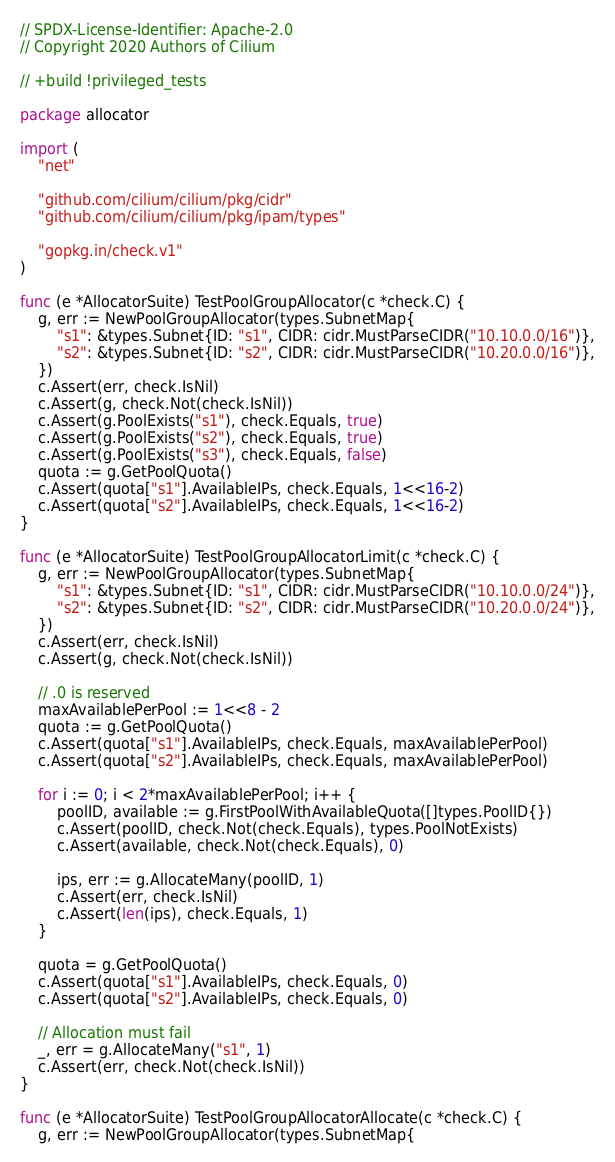<code> <loc_0><loc_0><loc_500><loc_500><_Go_>// SPDX-License-Identifier: Apache-2.0
// Copyright 2020 Authors of Cilium

// +build !privileged_tests

package allocator

import (
	"net"

	"github.com/cilium/cilium/pkg/cidr"
	"github.com/cilium/cilium/pkg/ipam/types"

	"gopkg.in/check.v1"
)

func (e *AllocatorSuite) TestPoolGroupAllocator(c *check.C) {
	g, err := NewPoolGroupAllocator(types.SubnetMap{
		"s1": &types.Subnet{ID: "s1", CIDR: cidr.MustParseCIDR("10.10.0.0/16")},
		"s2": &types.Subnet{ID: "s2", CIDR: cidr.MustParseCIDR("10.20.0.0/16")},
	})
	c.Assert(err, check.IsNil)
	c.Assert(g, check.Not(check.IsNil))
	c.Assert(g.PoolExists("s1"), check.Equals, true)
	c.Assert(g.PoolExists("s2"), check.Equals, true)
	c.Assert(g.PoolExists("s3"), check.Equals, false)
	quota := g.GetPoolQuota()
	c.Assert(quota["s1"].AvailableIPs, check.Equals, 1<<16-2)
	c.Assert(quota["s2"].AvailableIPs, check.Equals, 1<<16-2)
}

func (e *AllocatorSuite) TestPoolGroupAllocatorLimit(c *check.C) {
	g, err := NewPoolGroupAllocator(types.SubnetMap{
		"s1": &types.Subnet{ID: "s1", CIDR: cidr.MustParseCIDR("10.10.0.0/24")},
		"s2": &types.Subnet{ID: "s2", CIDR: cidr.MustParseCIDR("10.20.0.0/24")},
	})
	c.Assert(err, check.IsNil)
	c.Assert(g, check.Not(check.IsNil))

	// .0 is reserved
	maxAvailablePerPool := 1<<8 - 2
	quota := g.GetPoolQuota()
	c.Assert(quota["s1"].AvailableIPs, check.Equals, maxAvailablePerPool)
	c.Assert(quota["s2"].AvailableIPs, check.Equals, maxAvailablePerPool)

	for i := 0; i < 2*maxAvailablePerPool; i++ {
		poolID, available := g.FirstPoolWithAvailableQuota([]types.PoolID{})
		c.Assert(poolID, check.Not(check.Equals), types.PoolNotExists)
		c.Assert(available, check.Not(check.Equals), 0)

		ips, err := g.AllocateMany(poolID, 1)
		c.Assert(err, check.IsNil)
		c.Assert(len(ips), check.Equals, 1)
	}

	quota = g.GetPoolQuota()
	c.Assert(quota["s1"].AvailableIPs, check.Equals, 0)
	c.Assert(quota["s2"].AvailableIPs, check.Equals, 0)

	// Allocation must fail
	_, err = g.AllocateMany("s1", 1)
	c.Assert(err, check.Not(check.IsNil))
}

func (e *AllocatorSuite) TestPoolGroupAllocatorAllocate(c *check.C) {
	g, err := NewPoolGroupAllocator(types.SubnetMap{</code> 